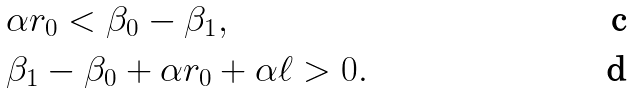Convert formula to latex. <formula><loc_0><loc_0><loc_500><loc_500>& \alpha r _ { 0 } < \beta _ { 0 } - \beta _ { 1 } , \\ & \beta _ { 1 } - \beta _ { 0 } + \alpha r _ { 0 } + \alpha \ell > 0 .</formula> 